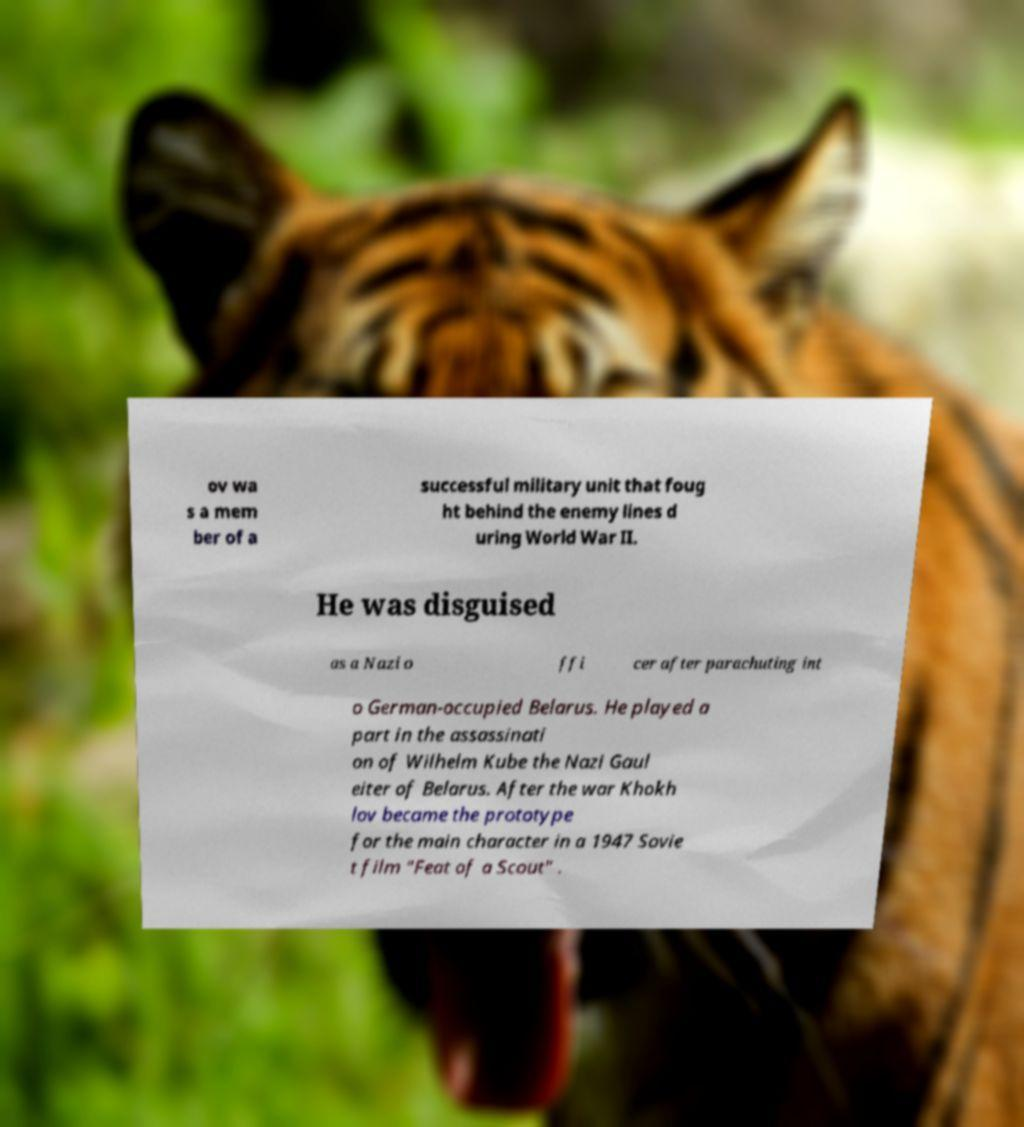For documentation purposes, I need the text within this image transcribed. Could you provide that? ov wa s a mem ber of a successful military unit that foug ht behind the enemy lines d uring World War II. He was disguised as a Nazi o ffi cer after parachuting int o German-occupied Belarus. He played a part in the assassinati on of Wilhelm Kube the Nazi Gaul eiter of Belarus. After the war Khokh lov became the prototype for the main character in a 1947 Sovie t film "Feat of a Scout" . 